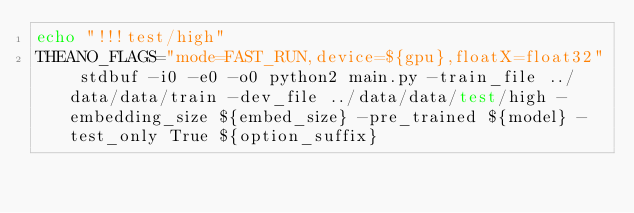Convert code to text. <code><loc_0><loc_0><loc_500><loc_500><_Bash_>echo "!!!test/high"
THEANO_FLAGS="mode=FAST_RUN,device=${gpu},floatX=float32" stdbuf -i0 -e0 -o0 python2 main.py -train_file ../data/data/train -dev_file ../data/data/test/high -embedding_size ${embed_size} -pre_trained ${model} -test_only True ${option_suffix}
</code> 